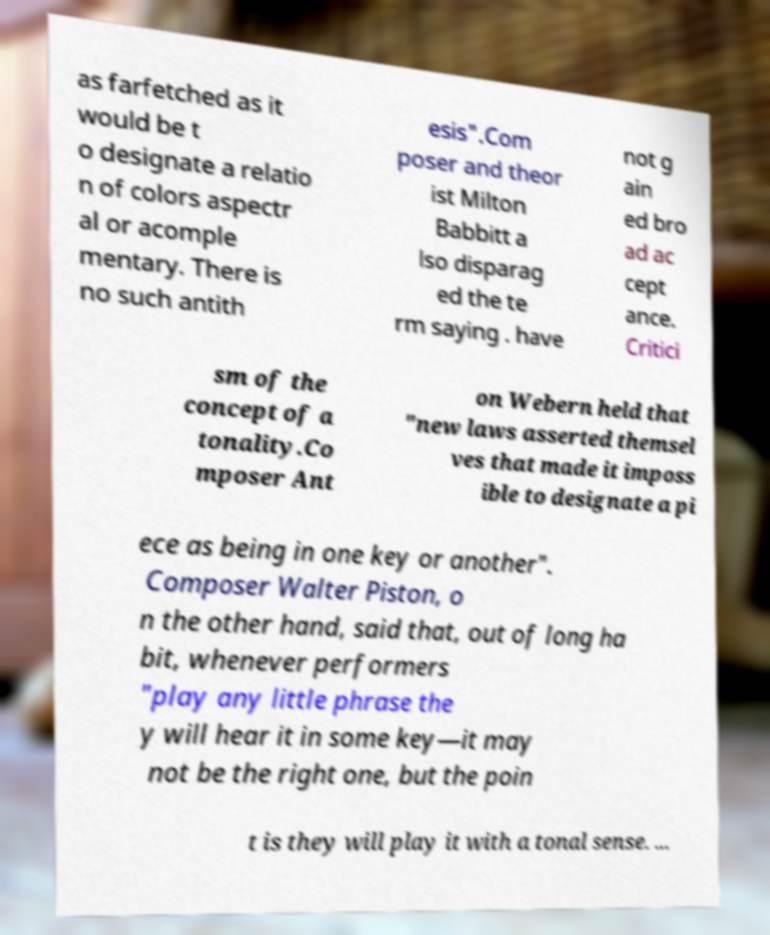Please identify and transcribe the text found in this image. as farfetched as it would be t o designate a relatio n of colors aspectr al or acomple mentary. There is no such antith esis".Com poser and theor ist Milton Babbitt a lso disparag ed the te rm saying . have not g ain ed bro ad ac cept ance. Critici sm of the concept of a tonality.Co mposer Ant on Webern held that "new laws asserted themsel ves that made it imposs ible to designate a pi ece as being in one key or another". Composer Walter Piston, o n the other hand, said that, out of long ha bit, whenever performers "play any little phrase the y will hear it in some key—it may not be the right one, but the poin t is they will play it with a tonal sense. ... 